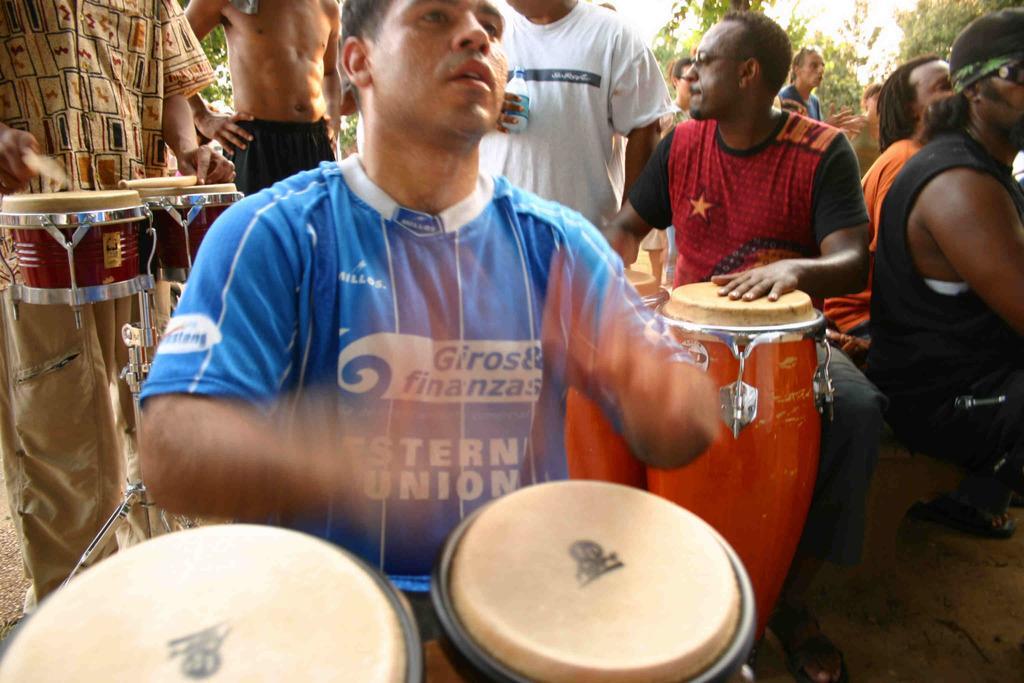Could you give a brief overview of what you see in this image? Few persons are standing. Few persons sitting. These three persons playing musical instrument. On the background we can see trees. 